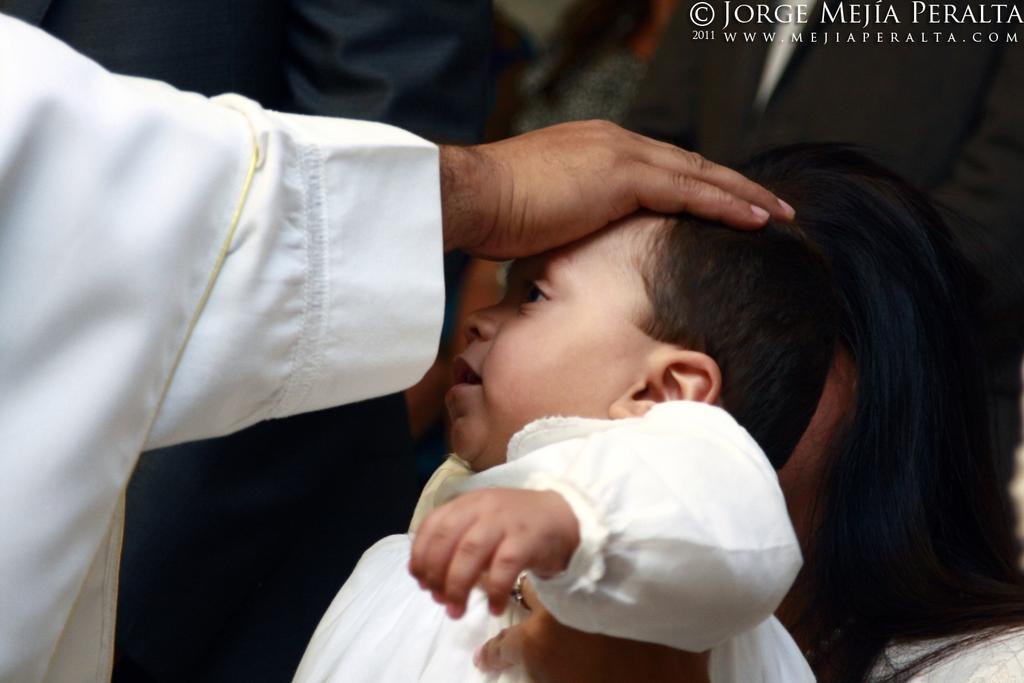What is the main action taking place in the image? There is a person giving blessings to a kid in the image. Are there any other people present in the image? Yes, there are other people present in the image. Can you describe any additional features of the image? There is a watermark in the top right corner of the image. What is the purpose of the swimming pool in the image? There is no swimming pool present in the image. 